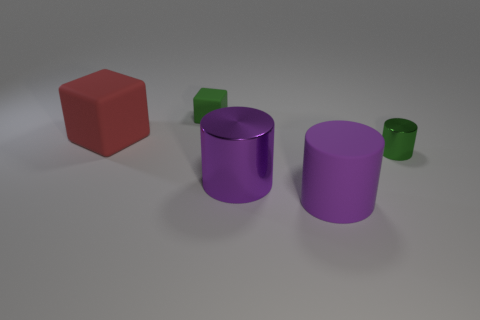The purple object behind the large rubber object to the right of the small object behind the red thing is what shape?
Provide a succinct answer. Cylinder. What shape is the big matte thing in front of the small green shiny cylinder?
Offer a terse response. Cylinder. Do the green cube and the block that is in front of the small green matte block have the same material?
Give a very brief answer. Yes. How many other objects are the same shape as the small green rubber object?
Offer a terse response. 1. There is a tiny cylinder; is its color the same as the rubber cube on the left side of the green rubber cube?
Provide a succinct answer. No. There is a rubber thing left of the tiny green object that is to the left of the matte cylinder; what is its shape?
Ensure brevity in your answer.  Cube. There is a rubber object that is the same color as the tiny metal cylinder; what size is it?
Your answer should be very brief. Small. There is a small green object behind the big red matte block; does it have the same shape as the red object?
Offer a very short reply. Yes. Are there more large purple cylinders that are behind the large purple rubber cylinder than large red cubes that are behind the big red matte object?
Give a very brief answer. Yes. How many big things are behind the purple rubber object in front of the tiny green matte block?
Provide a short and direct response. 2. 